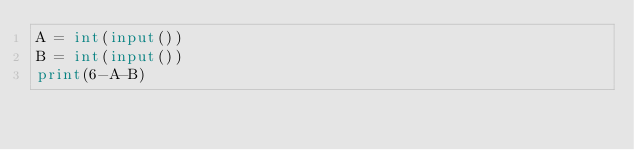<code> <loc_0><loc_0><loc_500><loc_500><_Python_>A = int(input())
B = int(input())
print(6-A-B)</code> 